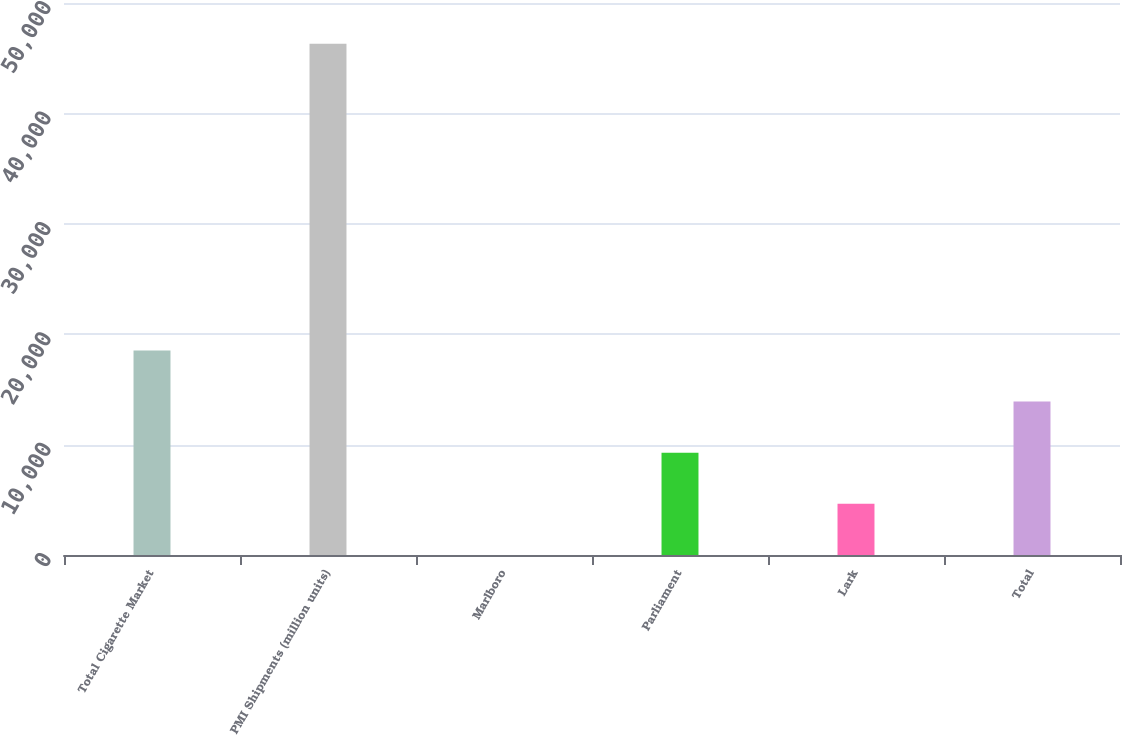<chart> <loc_0><loc_0><loc_500><loc_500><bar_chart><fcel>Total Cigarette Market<fcel>PMI Shipments (million units)<fcel>Marlboro<fcel>Parliament<fcel>Lark<fcel>Total<nl><fcel>18528.8<fcel>46309<fcel>8.6<fcel>9268.68<fcel>4638.64<fcel>13898.7<nl></chart> 